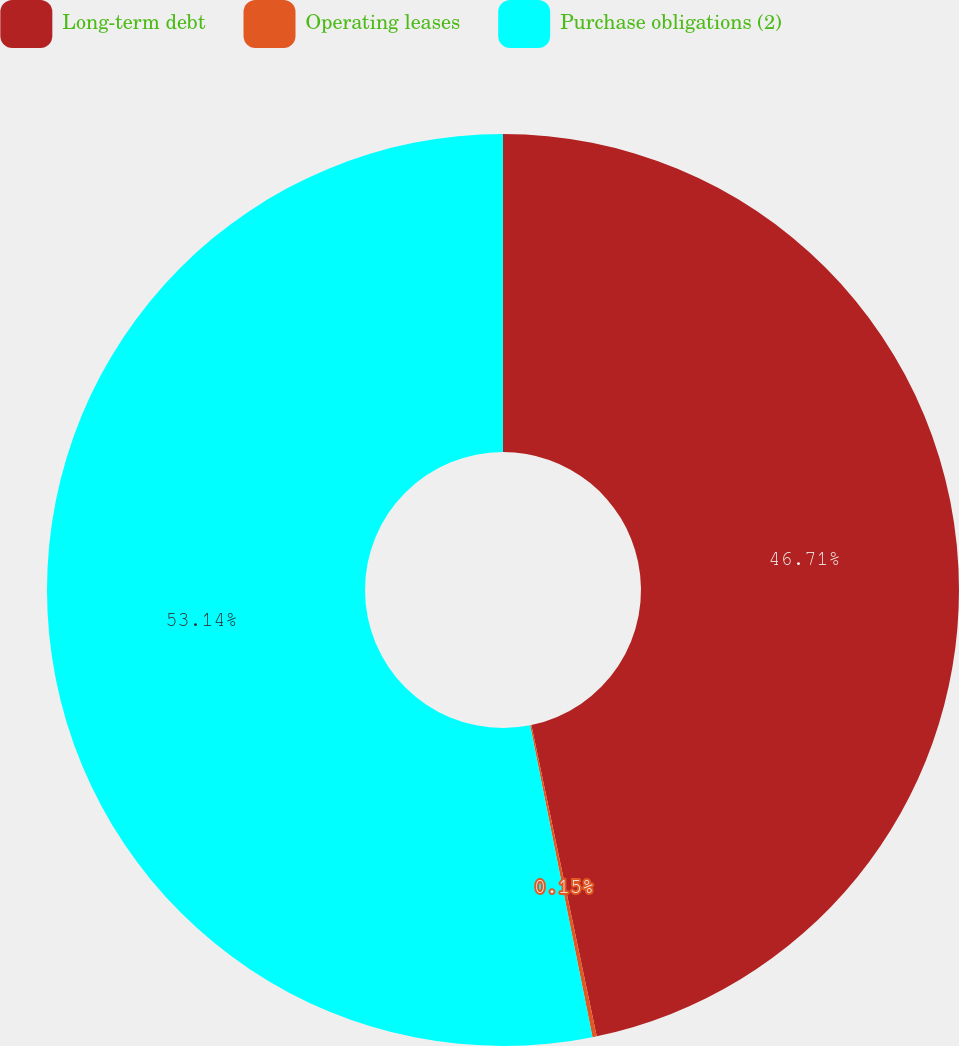Convert chart to OTSL. <chart><loc_0><loc_0><loc_500><loc_500><pie_chart><fcel>Long-term debt<fcel>Operating leases<fcel>Purchase obligations (2)<nl><fcel>46.71%<fcel>0.15%<fcel>53.15%<nl></chart> 